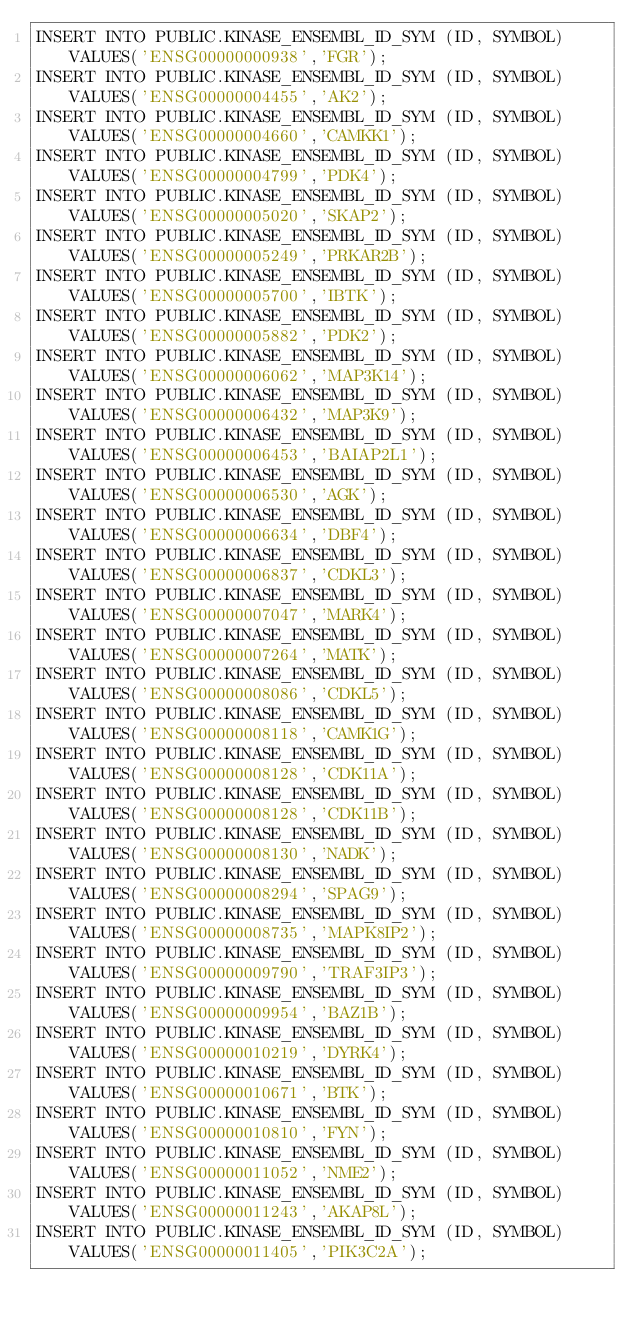<code> <loc_0><loc_0><loc_500><loc_500><_SQL_>INSERT INTO PUBLIC.KINASE_ENSEMBL_ID_SYM (ID, SYMBOL) VALUES('ENSG00000000938','FGR'); 
INSERT INTO PUBLIC.KINASE_ENSEMBL_ID_SYM (ID, SYMBOL) VALUES('ENSG00000004455','AK2'); 
INSERT INTO PUBLIC.KINASE_ENSEMBL_ID_SYM (ID, SYMBOL) VALUES('ENSG00000004660','CAMKK1'); 
INSERT INTO PUBLIC.KINASE_ENSEMBL_ID_SYM (ID, SYMBOL) VALUES('ENSG00000004799','PDK4'); 
INSERT INTO PUBLIC.KINASE_ENSEMBL_ID_SYM (ID, SYMBOL) VALUES('ENSG00000005020','SKAP2'); 
INSERT INTO PUBLIC.KINASE_ENSEMBL_ID_SYM (ID, SYMBOL) VALUES('ENSG00000005249','PRKAR2B'); 
INSERT INTO PUBLIC.KINASE_ENSEMBL_ID_SYM (ID, SYMBOL) VALUES('ENSG00000005700','IBTK'); 
INSERT INTO PUBLIC.KINASE_ENSEMBL_ID_SYM (ID, SYMBOL) VALUES('ENSG00000005882','PDK2'); 
INSERT INTO PUBLIC.KINASE_ENSEMBL_ID_SYM (ID, SYMBOL) VALUES('ENSG00000006062','MAP3K14'); 
INSERT INTO PUBLIC.KINASE_ENSEMBL_ID_SYM (ID, SYMBOL) VALUES('ENSG00000006432','MAP3K9'); 
INSERT INTO PUBLIC.KINASE_ENSEMBL_ID_SYM (ID, SYMBOL) VALUES('ENSG00000006453','BAIAP2L1'); 
INSERT INTO PUBLIC.KINASE_ENSEMBL_ID_SYM (ID, SYMBOL) VALUES('ENSG00000006530','AGK'); 
INSERT INTO PUBLIC.KINASE_ENSEMBL_ID_SYM (ID, SYMBOL) VALUES('ENSG00000006634','DBF4'); 
INSERT INTO PUBLIC.KINASE_ENSEMBL_ID_SYM (ID, SYMBOL) VALUES('ENSG00000006837','CDKL3'); 
INSERT INTO PUBLIC.KINASE_ENSEMBL_ID_SYM (ID, SYMBOL) VALUES('ENSG00000007047','MARK4'); 
INSERT INTO PUBLIC.KINASE_ENSEMBL_ID_SYM (ID, SYMBOL) VALUES('ENSG00000007264','MATK'); 
INSERT INTO PUBLIC.KINASE_ENSEMBL_ID_SYM (ID, SYMBOL) VALUES('ENSG00000008086','CDKL5'); 
INSERT INTO PUBLIC.KINASE_ENSEMBL_ID_SYM (ID, SYMBOL) VALUES('ENSG00000008118','CAMK1G'); 
INSERT INTO PUBLIC.KINASE_ENSEMBL_ID_SYM (ID, SYMBOL) VALUES('ENSG00000008128','CDK11A'); 
INSERT INTO PUBLIC.KINASE_ENSEMBL_ID_SYM (ID, SYMBOL) VALUES('ENSG00000008128','CDK11B'); 
INSERT INTO PUBLIC.KINASE_ENSEMBL_ID_SYM (ID, SYMBOL) VALUES('ENSG00000008130','NADK'); 
INSERT INTO PUBLIC.KINASE_ENSEMBL_ID_SYM (ID, SYMBOL) VALUES('ENSG00000008294','SPAG9'); 
INSERT INTO PUBLIC.KINASE_ENSEMBL_ID_SYM (ID, SYMBOL) VALUES('ENSG00000008735','MAPK8IP2'); 
INSERT INTO PUBLIC.KINASE_ENSEMBL_ID_SYM (ID, SYMBOL) VALUES('ENSG00000009790','TRAF3IP3'); 
INSERT INTO PUBLIC.KINASE_ENSEMBL_ID_SYM (ID, SYMBOL) VALUES('ENSG00000009954','BAZ1B'); 
INSERT INTO PUBLIC.KINASE_ENSEMBL_ID_SYM (ID, SYMBOL) VALUES('ENSG00000010219','DYRK4'); 
INSERT INTO PUBLIC.KINASE_ENSEMBL_ID_SYM (ID, SYMBOL) VALUES('ENSG00000010671','BTK'); 
INSERT INTO PUBLIC.KINASE_ENSEMBL_ID_SYM (ID, SYMBOL) VALUES('ENSG00000010810','FYN'); 
INSERT INTO PUBLIC.KINASE_ENSEMBL_ID_SYM (ID, SYMBOL) VALUES('ENSG00000011052','NME2'); 
INSERT INTO PUBLIC.KINASE_ENSEMBL_ID_SYM (ID, SYMBOL) VALUES('ENSG00000011243','AKAP8L'); 
INSERT INTO PUBLIC.KINASE_ENSEMBL_ID_SYM (ID, SYMBOL) VALUES('ENSG00000011405','PIK3C2A'); </code> 